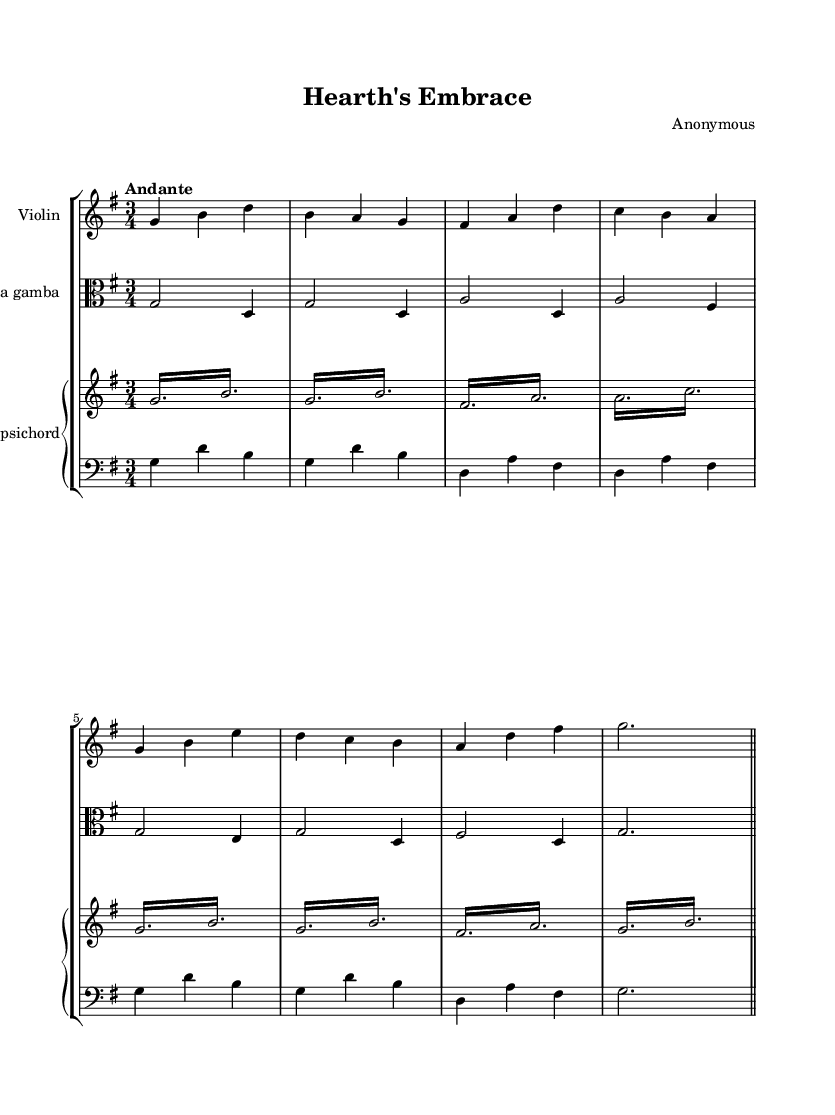What is the key signature of this music? The key signature is G major, which has one sharp (F#). This can be identified by looking at the key signature indicated at the beginning of the sheet music.
Answer: G major What is the time signature of this music? The time signature is 3/4, meaning there are three beats per measure and the quarter note gets one beat. This is visible at the beginning of the score next to the key signature.
Answer: 3/4 What is the tempo marking of this piece? The tempo marking is "Andante," indicating a moderately slow pace. This is usually found at the beginning of the sheet music, specifying the desired speed of the performance.
Answer: Andante Which instruments are featured in this piece? The instruments featured are Violin, Viola da gamba, and Harpsichord. This information can be found in the header and on the individual staves within the score.
Answer: Violin, Viola da gamba, Harpsichord How many measures are in the score? There are 8 measures in total, which can be counted by looking at the bar lines that separate each measure in the sheet music.
Answer: 8 What is the highest note played by the violin? The highest note played by the violin is D. This can be determined by reviewing the notes on the staff for the violin part and identifying the highest pitch.
Answer: D How does the harpsichord contribute to the texture of the piece? The harpsichord plays both right-hand melodic lines and left-hand harmonic support, creating a rich texture. By analyzing both the treble and bass staves for the harpsichord, we see it fills both roles effectively.
Answer: Rich texture 